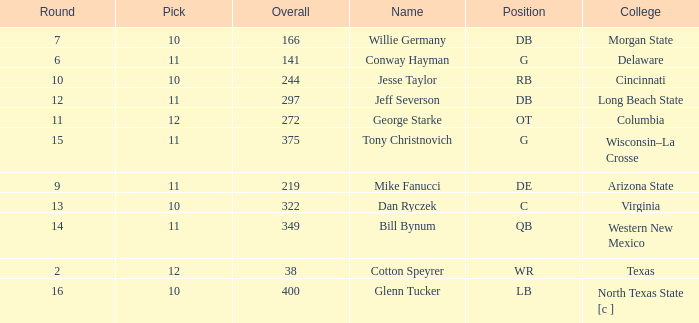What is the lowest round for an overall pick of 349 with a pick number in the round over 11? None. 